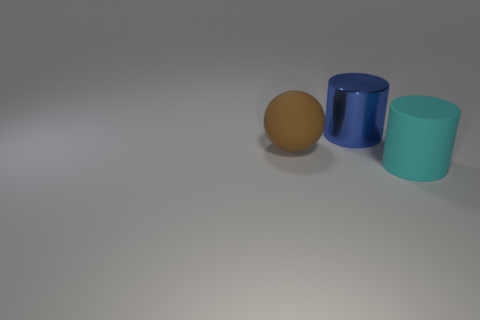Are there any other things that have the same size as the blue thing? Yes, the object on the far left, which appears to be a brown egg, is roughly the same size as the blue cylinder in the center. 